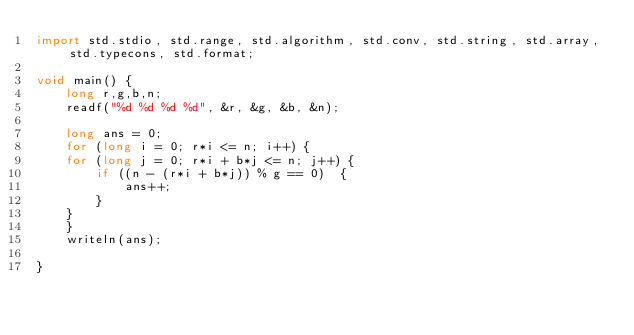<code> <loc_0><loc_0><loc_500><loc_500><_D_>import std.stdio, std.range, std.algorithm, std.conv, std.string, std.array, std.typecons, std.format;

void main() {
    long r,g,b,n;
    readf("%d %d %d %d", &r, &g, &b, &n);

    long ans = 0;
    for (long i = 0; r*i <= n; i++) {
    for (long j = 0; r*i + b*j <= n; j++) {
        if ((n - (r*i + b*j)) % g == 0)  {
            ans++;
        }
    }
    }
    writeln(ans);

}
</code> 